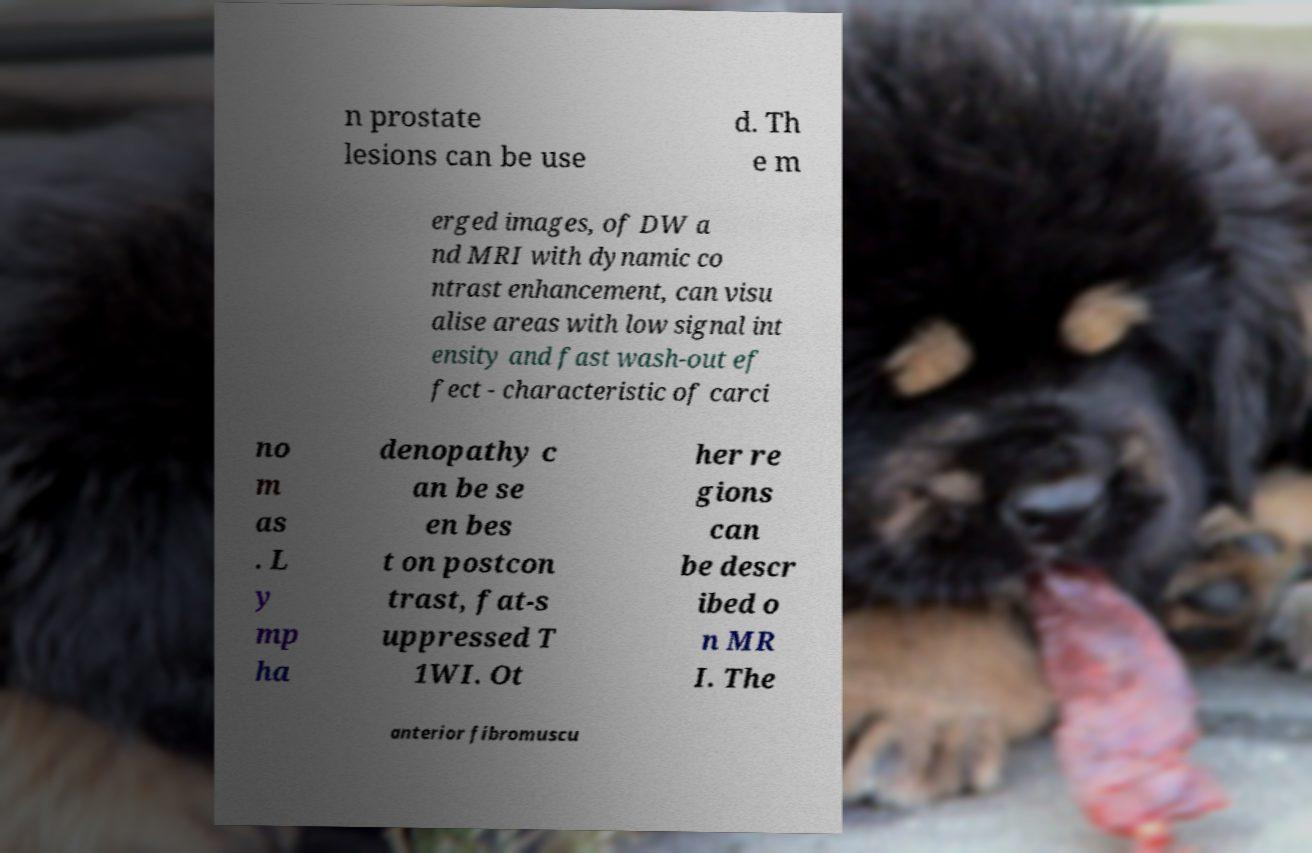There's text embedded in this image that I need extracted. Can you transcribe it verbatim? n prostate lesions can be use d. Th e m erged images, of DW a nd MRI with dynamic co ntrast enhancement, can visu alise areas with low signal int ensity and fast wash-out ef fect - characteristic of carci no m as . L y mp ha denopathy c an be se en bes t on postcon trast, fat-s uppressed T 1WI. Ot her re gions can be descr ibed o n MR I. The anterior fibromuscu 